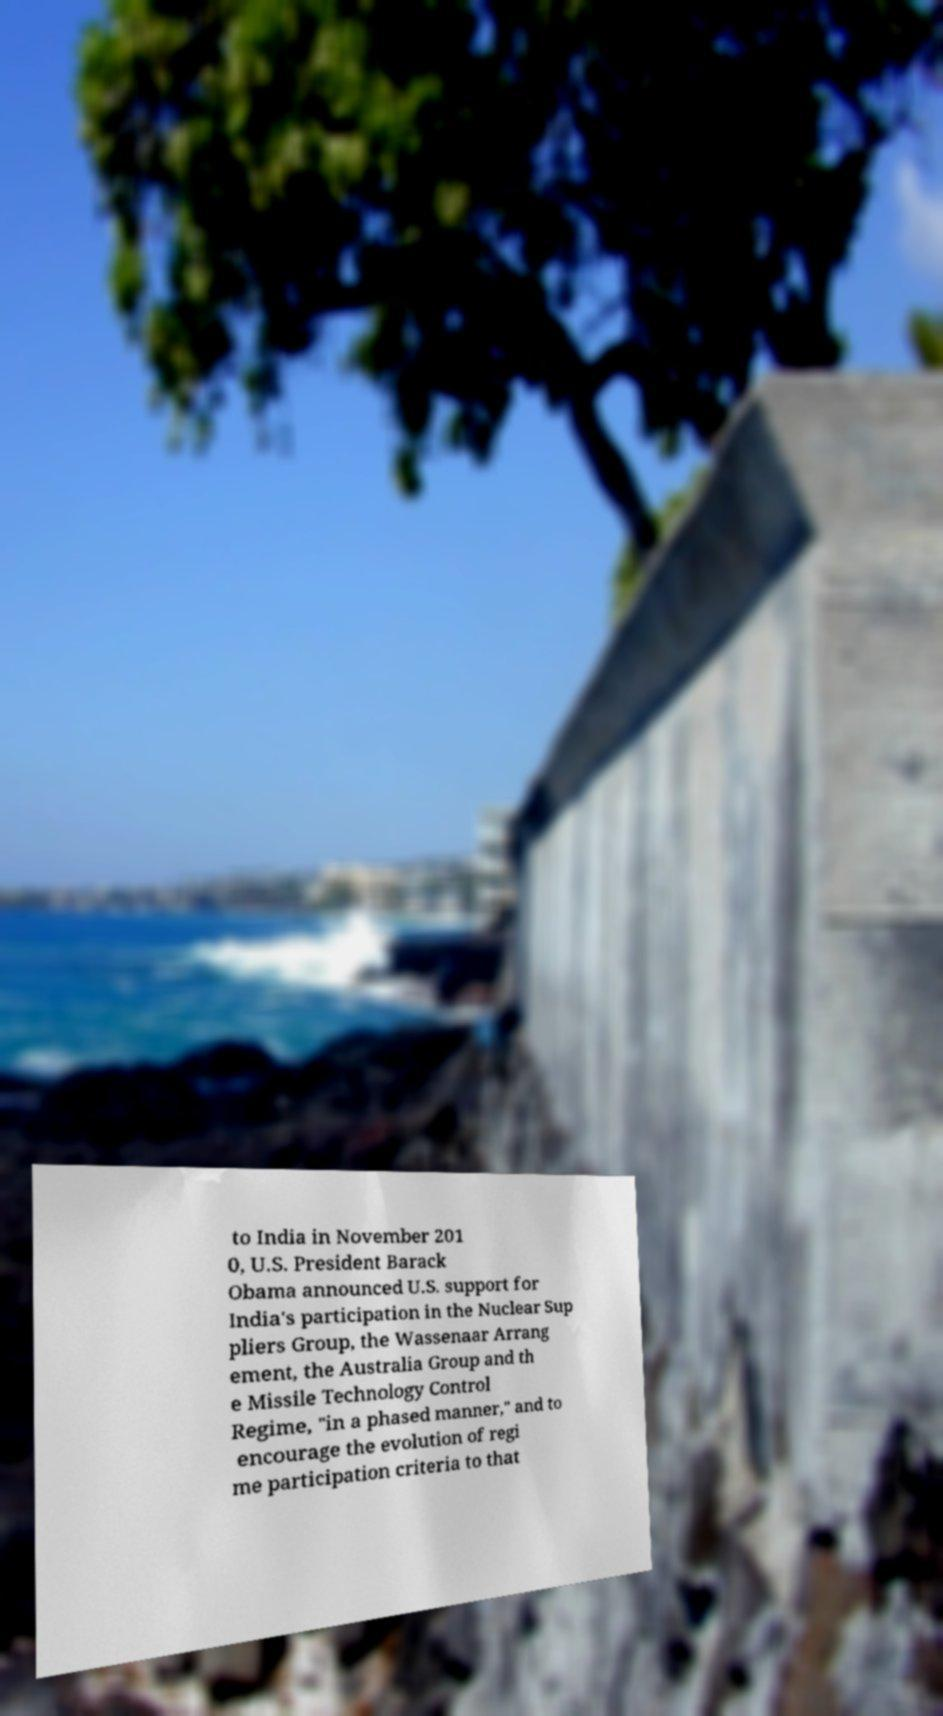For documentation purposes, I need the text within this image transcribed. Could you provide that? to India in November 201 0, U.S. President Barack Obama announced U.S. support for India's participation in the Nuclear Sup pliers Group, the Wassenaar Arrang ement, the Australia Group and th e Missile Technology Control Regime, "in a phased manner," and to encourage the evolution of regi me participation criteria to that 